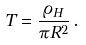<formula> <loc_0><loc_0><loc_500><loc_500>T = \frac { \varrho _ { H } } { \pi R ^ { 2 } } \, .</formula> 